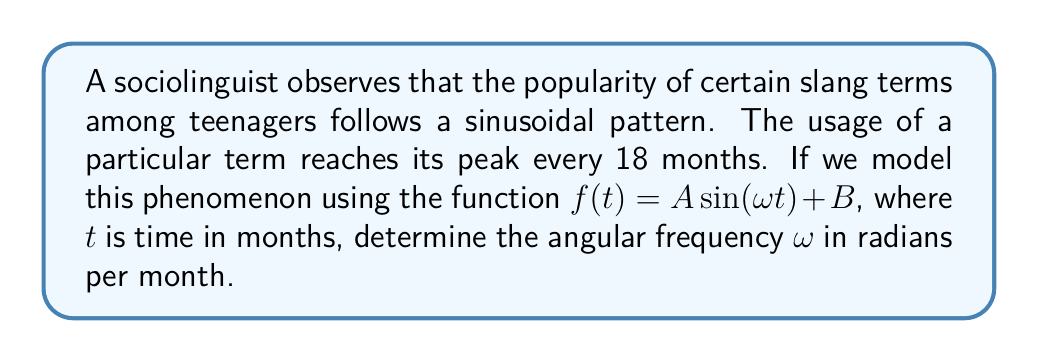Help me with this question. To solve this problem, we need to follow these steps:

1. Recall that the period of a sinusoidal function is given by:

   $T = \frac{2\pi}{\omega}$

   where $T$ is the period and $\omega$ is the angular frequency.

2. We are given that the period is 18 months. Let's substitute this into our equation:

   $18 = \frac{2\pi}{\omega}$

3. Now, we can solve for $\omega$:

   $\omega = \frac{2\pi}{18}$

4. Simplify:

   $\omega = \frac{\pi}{9}$

This gives us the angular frequency in radians per month.
Answer: $\frac{\pi}{9}$ radians/month 